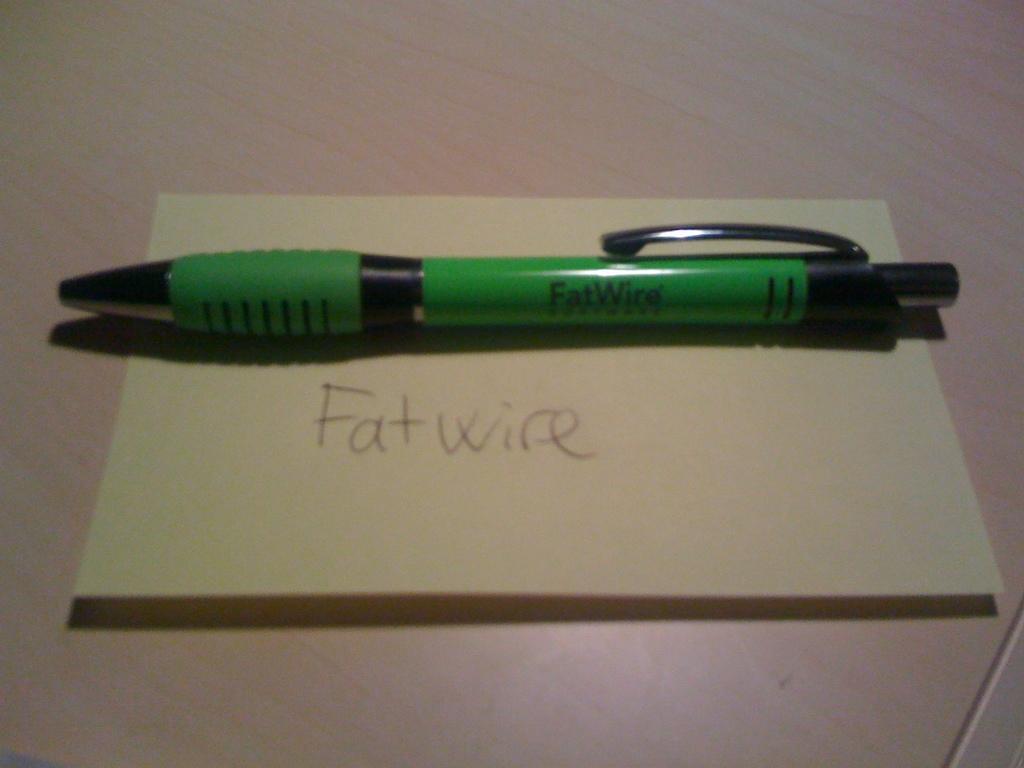Can you describe this image briefly? In this image, we can see a pen on the paper contains some written text. 